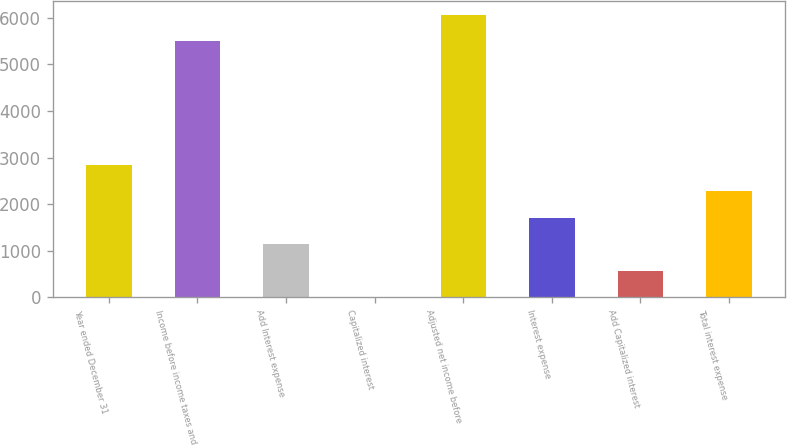Convert chart to OTSL. <chart><loc_0><loc_0><loc_500><loc_500><bar_chart><fcel>Year ended December 31<fcel>Income before income taxes and<fcel>Add Interest expense<fcel>Capitalized interest<fcel>Adjusted net income before<fcel>Interest expense<fcel>Add Capitalized interest<fcel>Total interest expense<nl><fcel>2850<fcel>5499<fcel>1140.6<fcel>1<fcel>6068.8<fcel>1710.4<fcel>570.8<fcel>2280.2<nl></chart> 